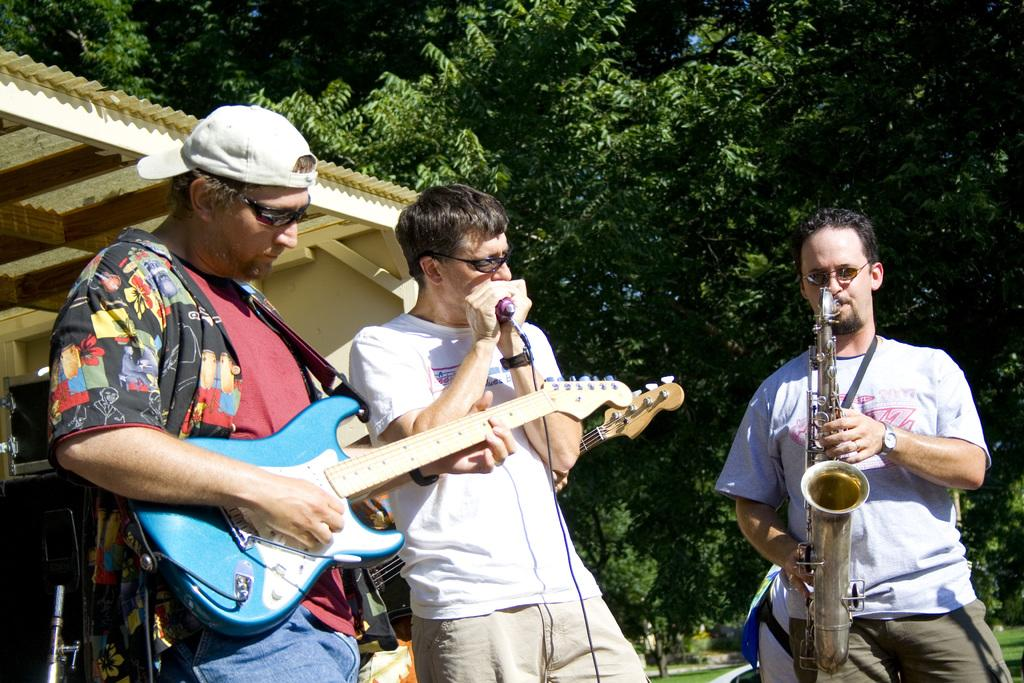How many people are in the image? There are three men in the image. What are the men doing in the image? The men are playing musical instruments. What can be seen in the background of the image? There are trees in the background of the image. What shape is the bath in the image? There is no bath present in the image. How does the music stop playing in the image? The image does not depict any sound or music, so it cannot show how the music stops playing. 